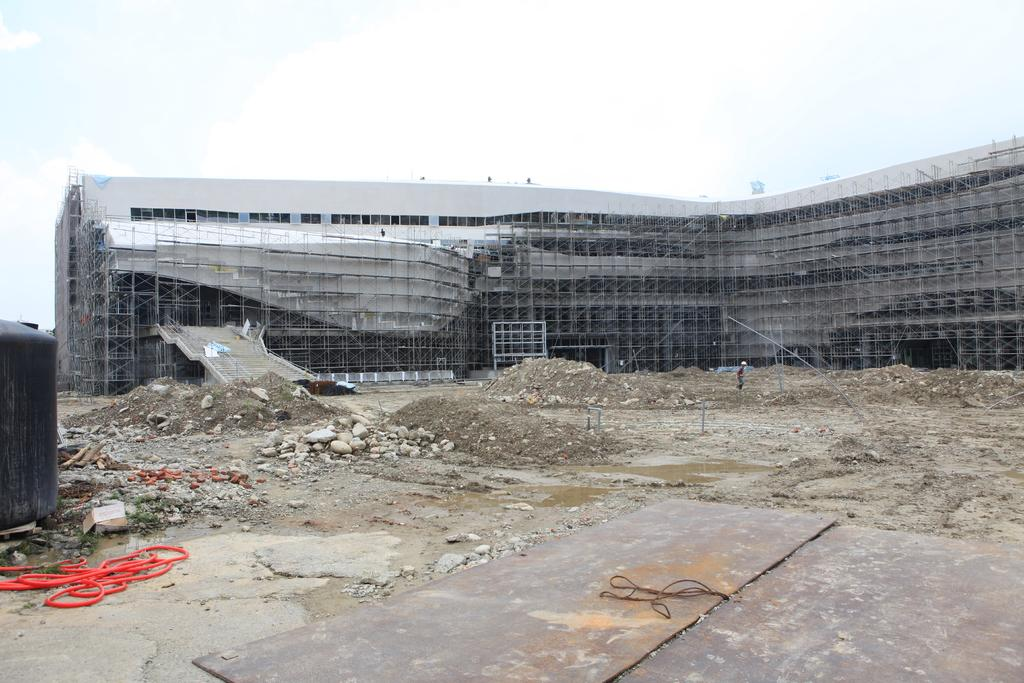What is located in the foreground of the image? There are raw materials in the foreground of the image. What can be seen on the left side of the image? There is a tanker and a tube on the left side of the image. What type of structures are visible in the background of the image? There is architecture visible in the background of the image}. Can you see a cart being pulled by a snail in the image? There is no cart or snail present in the image. 